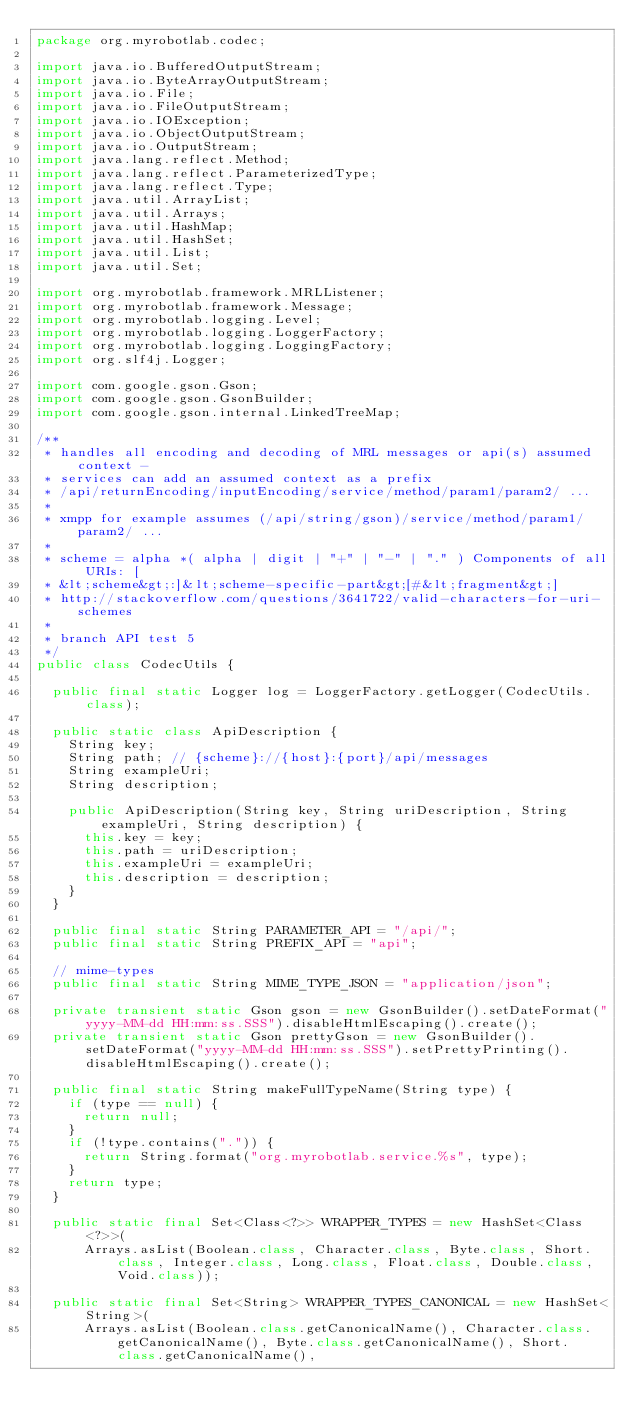<code> <loc_0><loc_0><loc_500><loc_500><_Java_>package org.myrobotlab.codec;

import java.io.BufferedOutputStream;
import java.io.ByteArrayOutputStream;
import java.io.File;
import java.io.FileOutputStream;
import java.io.IOException;
import java.io.ObjectOutputStream;
import java.io.OutputStream;
import java.lang.reflect.Method;
import java.lang.reflect.ParameterizedType;
import java.lang.reflect.Type;
import java.util.ArrayList;
import java.util.Arrays;
import java.util.HashMap;
import java.util.HashSet;
import java.util.List;
import java.util.Set;

import org.myrobotlab.framework.MRLListener;
import org.myrobotlab.framework.Message;
import org.myrobotlab.logging.Level;
import org.myrobotlab.logging.LoggerFactory;
import org.myrobotlab.logging.LoggingFactory;
import org.slf4j.Logger;

import com.google.gson.Gson;
import com.google.gson.GsonBuilder;
import com.google.gson.internal.LinkedTreeMap;

/**
 * handles all encoding and decoding of MRL messages or api(s) assumed context -
 * services can add an assumed context as a prefix
 * /api/returnEncoding/inputEncoding/service/method/param1/param2/ ...
 * 
 * xmpp for example assumes (/api/string/gson)/service/method/param1/param2/ ...
 * 
 * scheme = alpha *( alpha | digit | "+" | "-" | "." ) Components of all URIs: [
 * &lt;scheme&gt;:]&lt;scheme-specific-part&gt;[#&lt;fragment&gt;]
 * http://stackoverflow.com/questions/3641722/valid-characters-for-uri-schemes
 * 
 * branch API test 5
 */
public class CodecUtils {

  public final static Logger log = LoggerFactory.getLogger(CodecUtils.class);
  
  public static class ApiDescription {
    String key;
    String path; // {scheme}://{host}:{port}/api/messages
    String exampleUri;
    String description;

    public ApiDescription(String key, String uriDescription, String exampleUri, String description) {
      this.key = key;
      this.path = uriDescription;
      this.exampleUri = exampleUri;
      this.description = description;
    }
  }
  
  public final static String PARAMETER_API = "/api/";
  public final static String PREFIX_API = "api";

  // mime-types
  public final static String MIME_TYPE_JSON = "application/json";

  private transient static Gson gson = new GsonBuilder().setDateFormat("yyyy-MM-dd HH:mm:ss.SSS").disableHtmlEscaping().create();
  private transient static Gson prettyGson = new GsonBuilder().setDateFormat("yyyy-MM-dd HH:mm:ss.SSS").setPrettyPrinting().disableHtmlEscaping().create();

  public final static String makeFullTypeName(String type) {
    if (type == null) {
      return null;
    }
    if (!type.contains(".")) {
      return String.format("org.myrobotlab.service.%s", type);
    }
    return type;
  }

  public static final Set<Class<?>> WRAPPER_TYPES = new HashSet<Class<?>>(
      Arrays.asList(Boolean.class, Character.class, Byte.class, Short.class, Integer.class, Long.class, Float.class, Double.class, Void.class));

  public static final Set<String> WRAPPER_TYPES_CANONICAL = new HashSet<String>(
      Arrays.asList(Boolean.class.getCanonicalName(), Character.class.getCanonicalName(), Byte.class.getCanonicalName(), Short.class.getCanonicalName(),</code> 